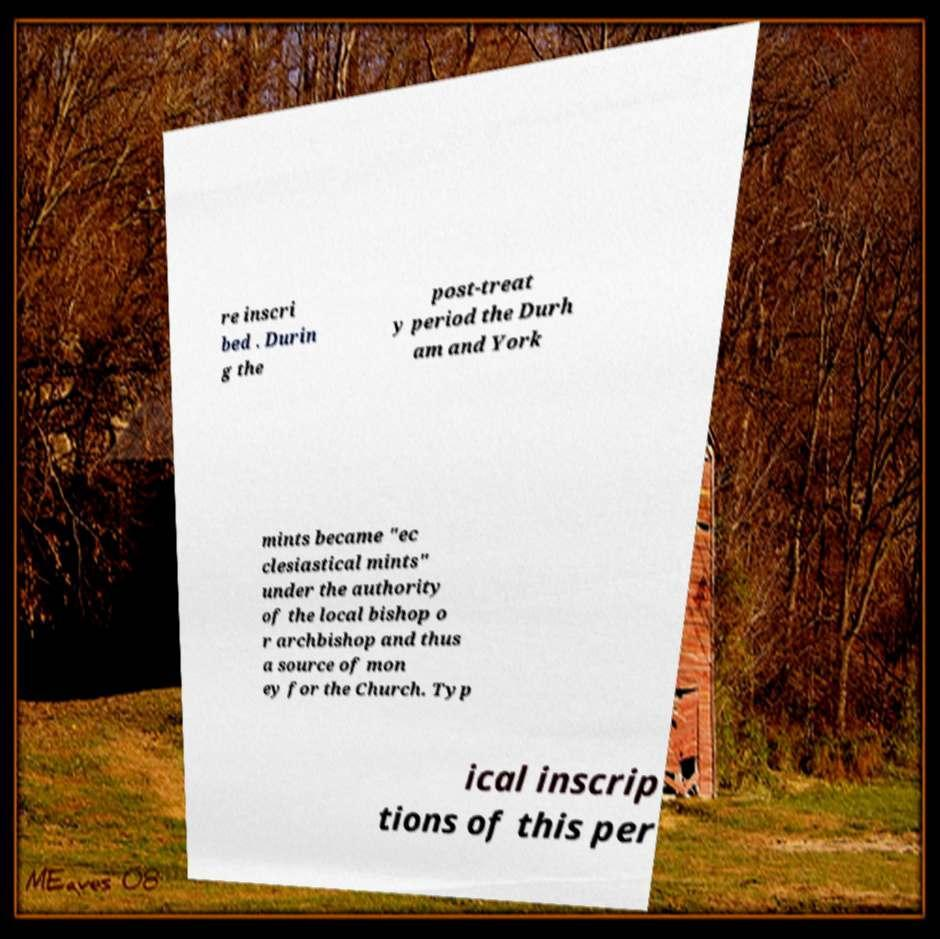Please read and relay the text visible in this image. What does it say? re inscri bed . Durin g the post-treat y period the Durh am and York mints became "ec clesiastical mints" under the authority of the local bishop o r archbishop and thus a source of mon ey for the Church. Typ ical inscrip tions of this per 